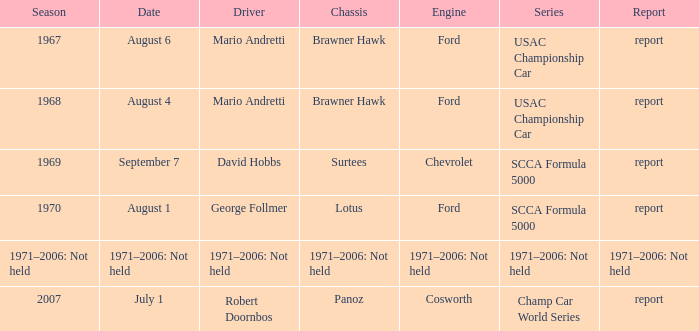Could you parse the entire table as a dict? {'header': ['Season', 'Date', 'Driver', 'Chassis', 'Engine', 'Series', 'Report'], 'rows': [['1967', 'August 6', 'Mario Andretti', 'Brawner Hawk', 'Ford', 'USAC Championship Car', 'report'], ['1968', 'August 4', 'Mario Andretti', 'Brawner Hawk', 'Ford', 'USAC Championship Car', 'report'], ['1969', 'September 7', 'David Hobbs', 'Surtees', 'Chevrolet', 'SCCA Formula 5000', 'report'], ['1970', 'August 1', 'George Follmer', 'Lotus', 'Ford', 'SCCA Formula 5000', 'report'], ['1971–2006: Not held', '1971–2006: Not held', '1971–2006: Not held', '1971–2006: Not held', '1971–2006: Not held', '1971–2006: Not held', '1971–2006: Not held'], ['2007', 'July 1', 'Robert Doornbos', 'Panoz', 'Cosworth', 'Champ Car World Series', 'report']]} Which engine is responsible for the USAC Championship Car? Ford, Ford. 